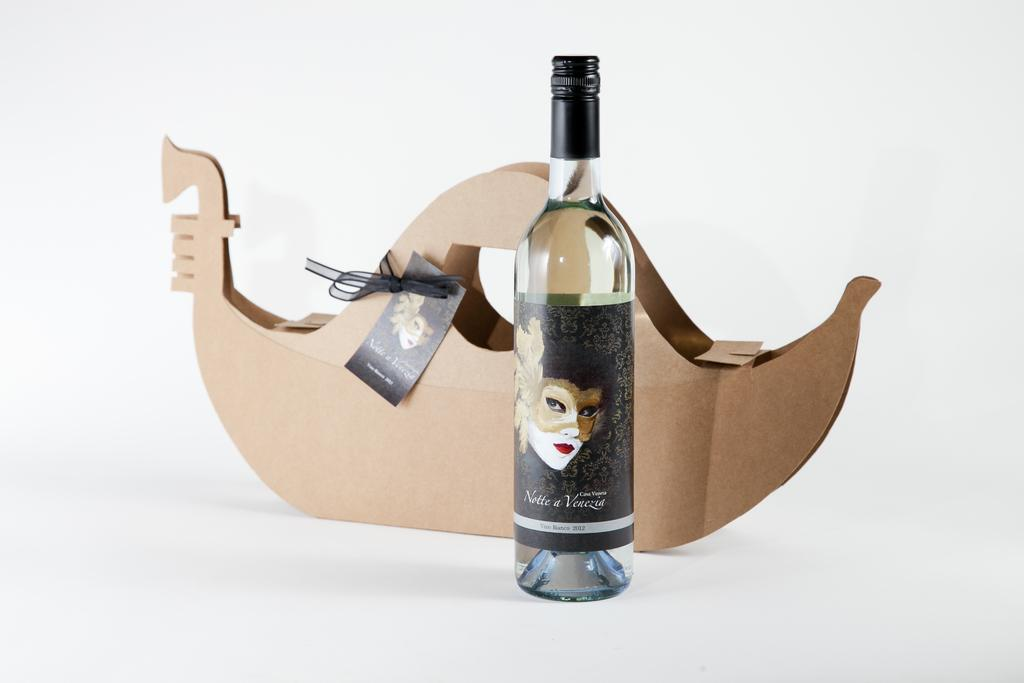<image>
Offer a succinct explanation of the picture presented. A bottle of Notte a Venezia wine bottle with its wrapping box. 